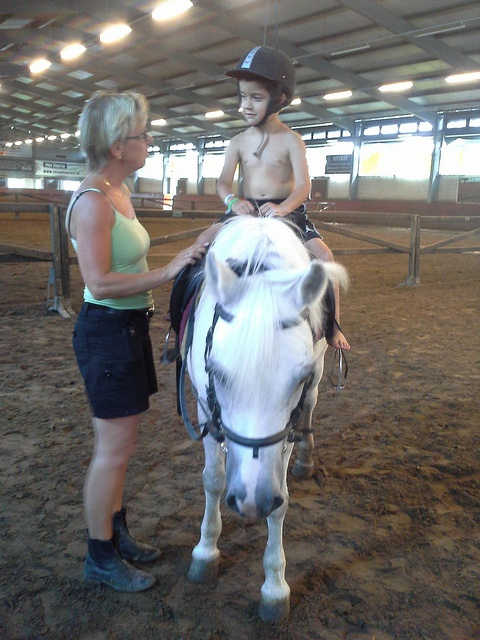Describe the objects in this image and their specific colors. I can see horse in black, lightblue, gray, and darkgray tones, people in black, gray, and darkgray tones, and people in black, darkgray, gray, and lightgray tones in this image. 